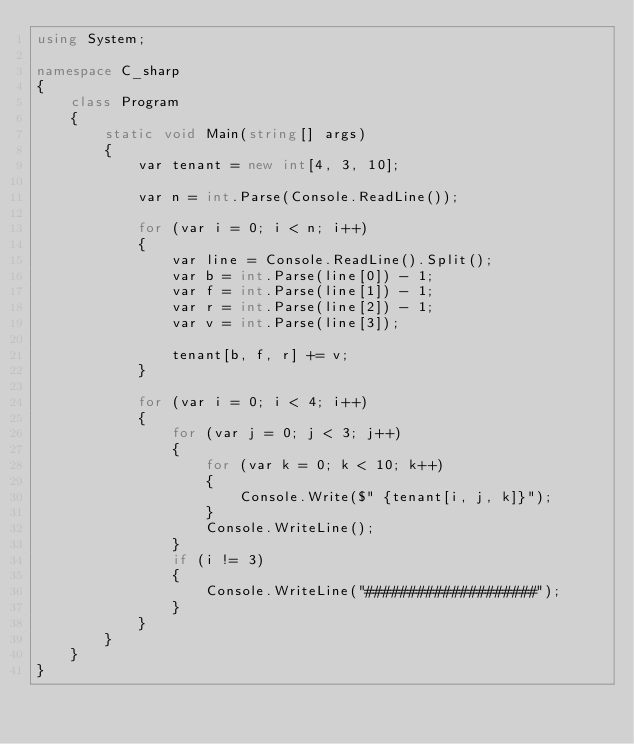<code> <loc_0><loc_0><loc_500><loc_500><_C#_>using System;

namespace C_sharp
{
    class Program
    {
        static void Main(string[] args)
        {
            var tenant = new int[4, 3, 10];

            var n = int.Parse(Console.ReadLine());

            for (var i = 0; i < n; i++)
            {
                var line = Console.ReadLine().Split();
                var b = int.Parse(line[0]) - 1;
                var f = int.Parse(line[1]) - 1;
                var r = int.Parse(line[2]) - 1;
                var v = int.Parse(line[3]);

                tenant[b, f, r] += v;
            }

            for (var i = 0; i < 4; i++)
            {
                for (var j = 0; j < 3; j++)
                {
                    for (var k = 0; k < 10; k++)
                    {
                        Console.Write($" {tenant[i, j, k]}");
                    }
                    Console.WriteLine();
                }
                if (i != 3)
                {
                    Console.WriteLine("####################");
                }
            }
        }
    }
}

</code> 